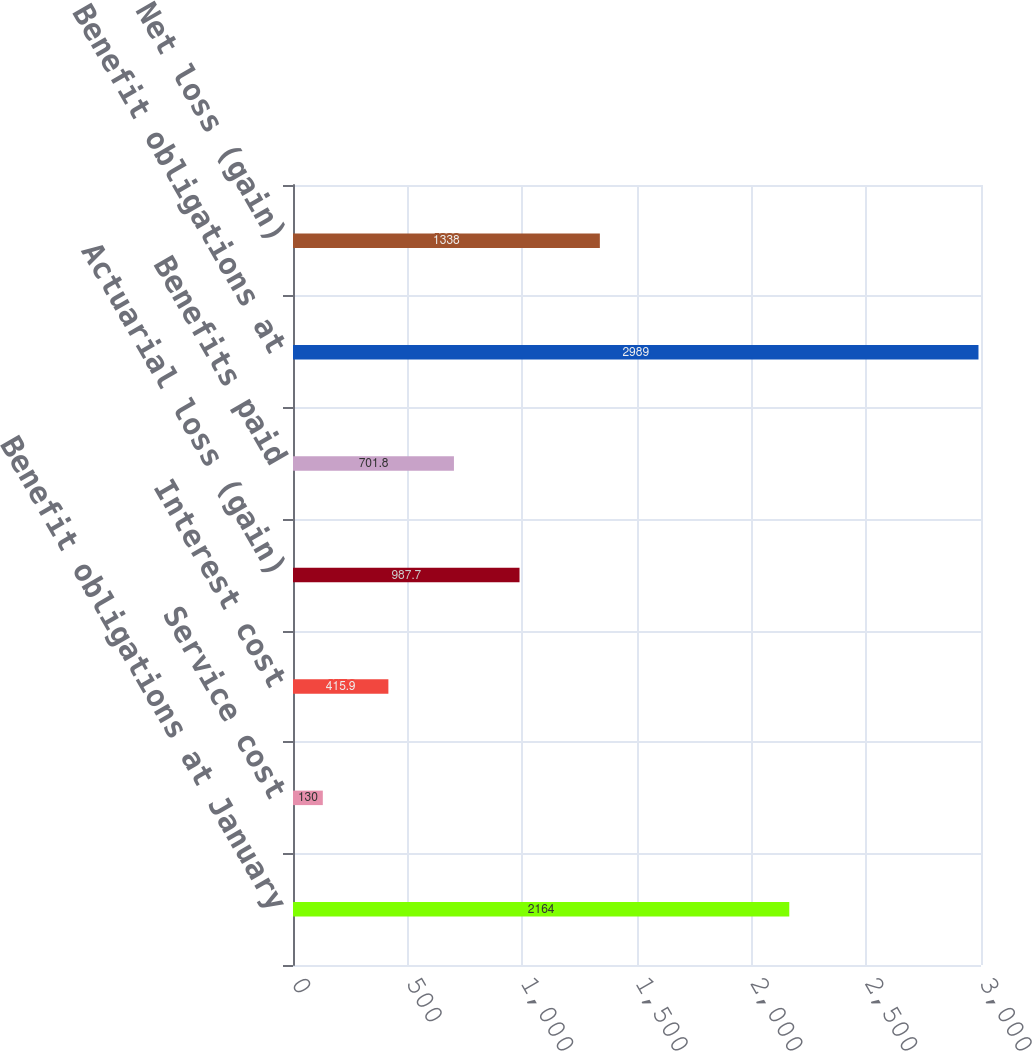Convert chart to OTSL. <chart><loc_0><loc_0><loc_500><loc_500><bar_chart><fcel>Benefit obligations at January<fcel>Service cost<fcel>Interest cost<fcel>Actuarial loss (gain)<fcel>Benefits paid<fcel>Benefit obligations at<fcel>Net loss (gain)<nl><fcel>2164<fcel>130<fcel>415.9<fcel>987.7<fcel>701.8<fcel>2989<fcel>1338<nl></chart> 